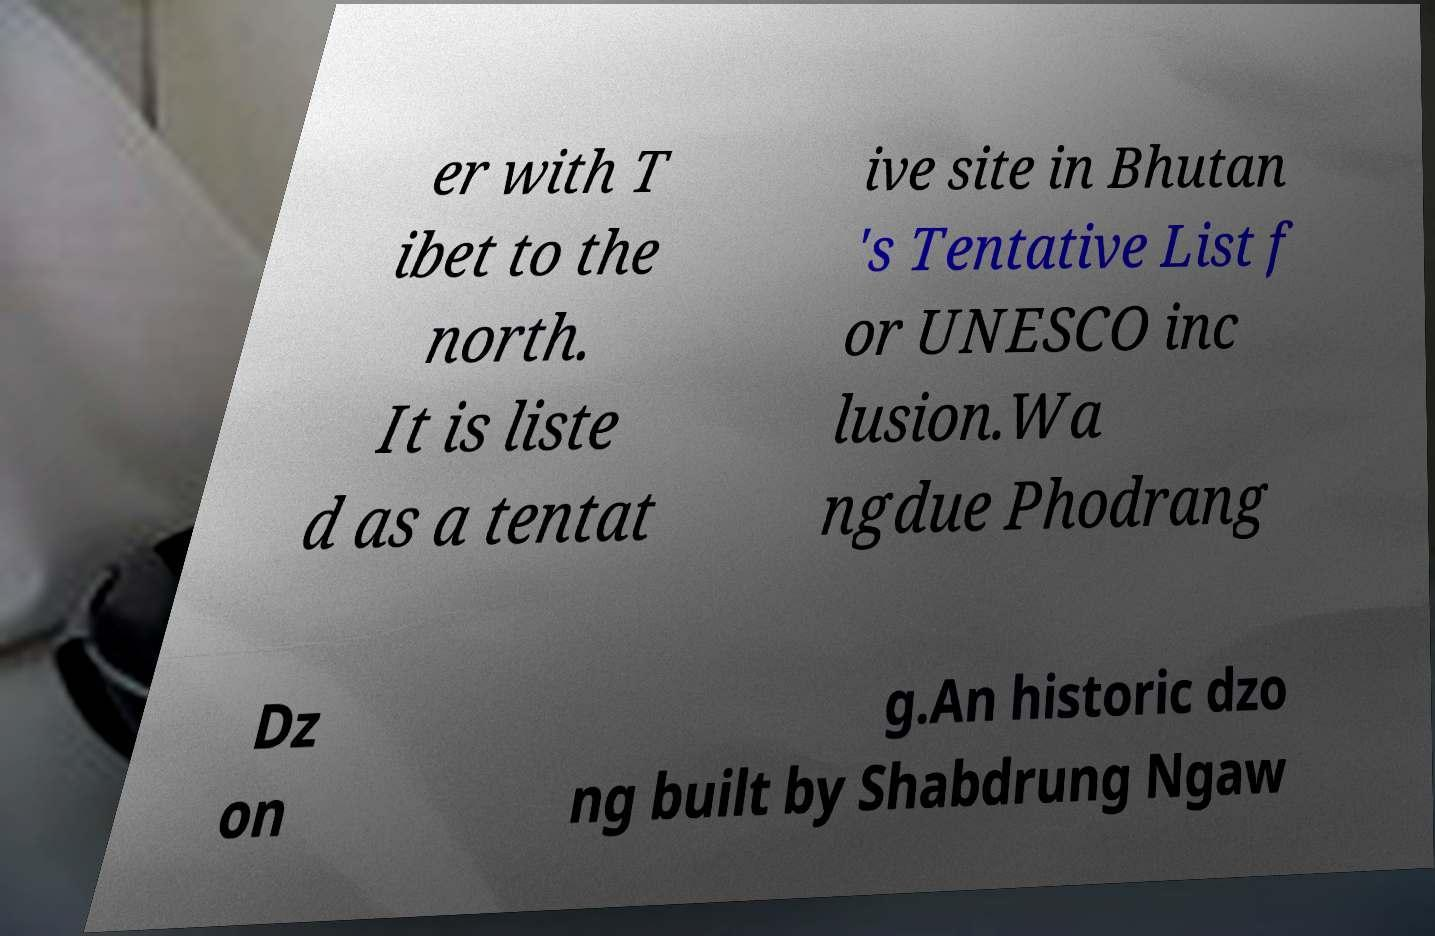For documentation purposes, I need the text within this image transcribed. Could you provide that? er with T ibet to the north. It is liste d as a tentat ive site in Bhutan 's Tentative List f or UNESCO inc lusion.Wa ngdue Phodrang Dz on g.An historic dzo ng built by Shabdrung Ngaw 